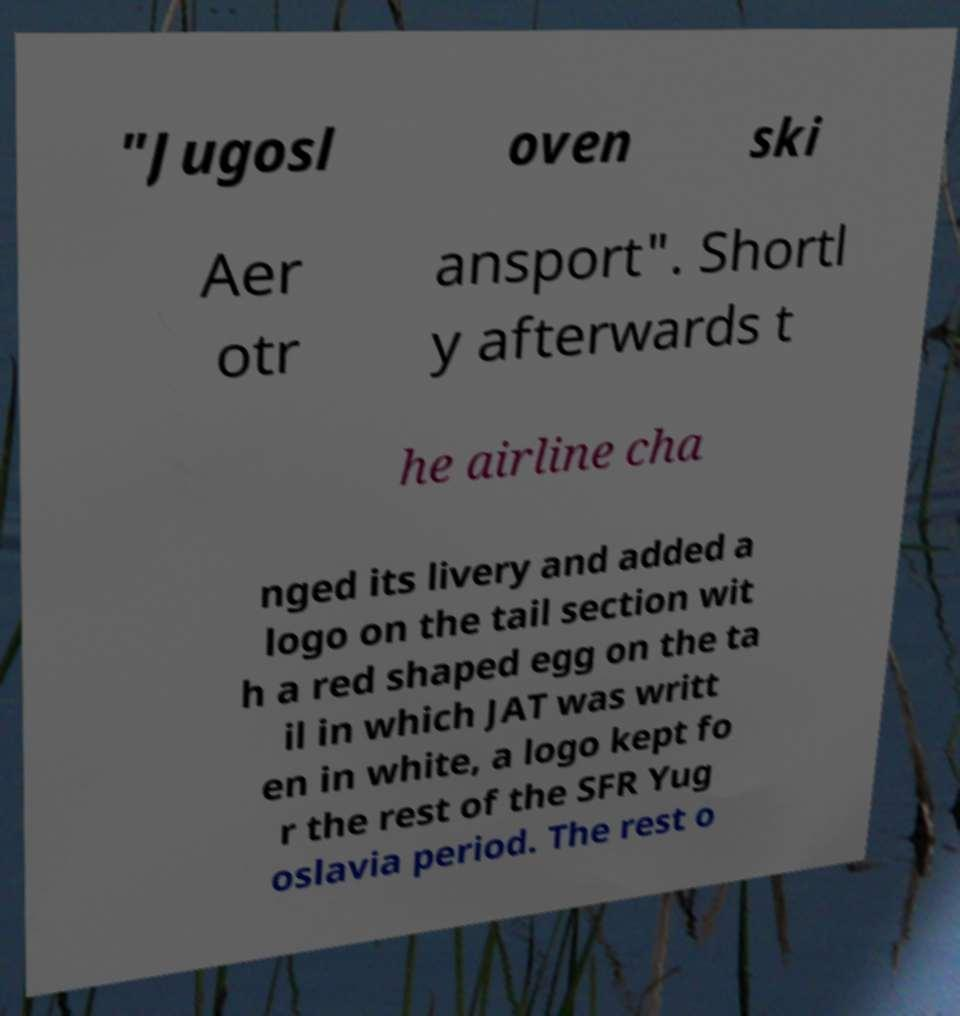Please identify and transcribe the text found in this image. "Jugosl oven ski Aer otr ansport". Shortl y afterwards t he airline cha nged its livery and added a logo on the tail section wit h a red shaped egg on the ta il in which JAT was writt en in white, a logo kept fo r the rest of the SFR Yug oslavia period. The rest o 